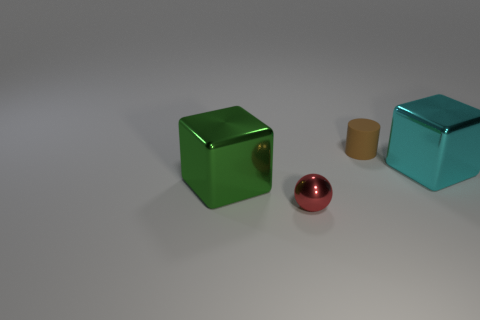Can you describe the objects in the image and their colors? Sure, there are three objects in the image. Starting from the left, there is a glossy green cube, a tiny red sphere in the middle, and a small glossy cyan cube to the right. 